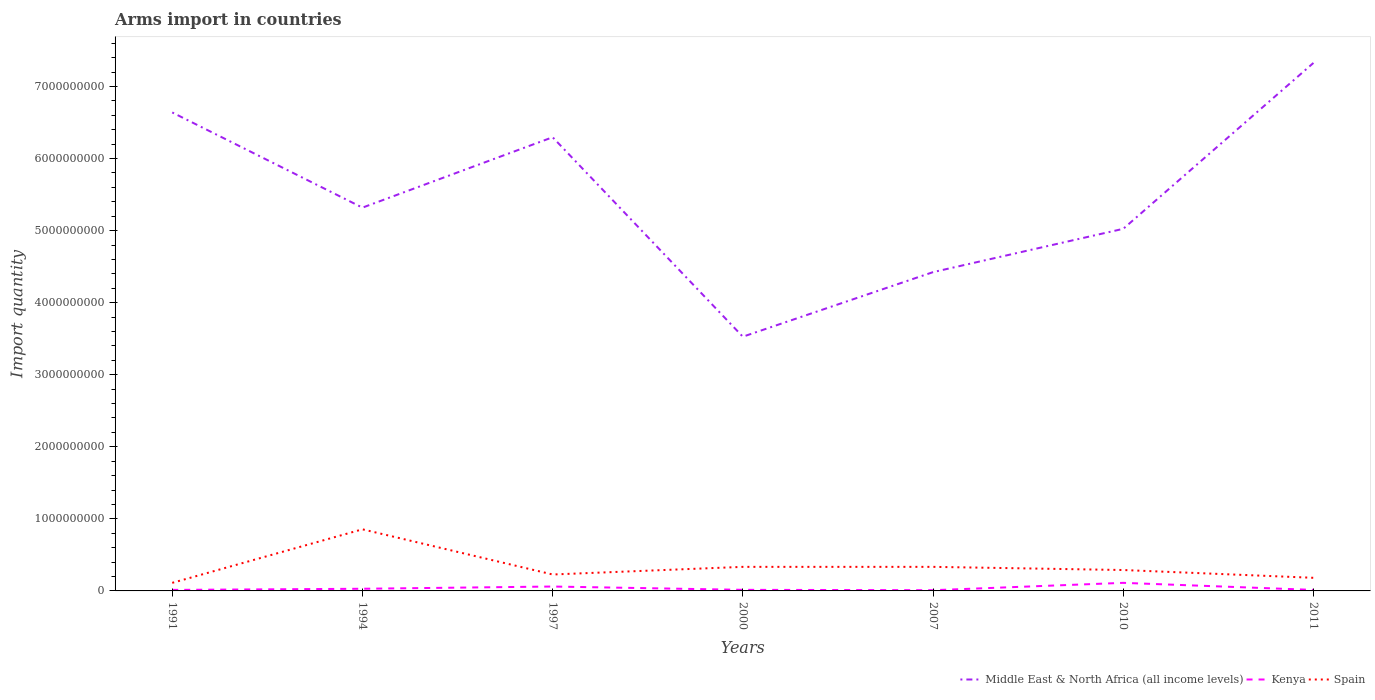Is the number of lines equal to the number of legend labels?
Offer a very short reply. Yes. Across all years, what is the maximum total arms import in Spain?
Give a very brief answer. 1.12e+08. In which year was the total arms import in Spain maximum?
Provide a short and direct response. 1991. What is the total total arms import in Spain in the graph?
Keep it short and to the point. 5.65e+08. What is the difference between the highest and the second highest total arms import in Spain?
Provide a succinct answer. 7.43e+08. How many years are there in the graph?
Keep it short and to the point. 7. Are the values on the major ticks of Y-axis written in scientific E-notation?
Your answer should be compact. No. How are the legend labels stacked?
Keep it short and to the point. Horizontal. What is the title of the graph?
Make the answer very short. Arms import in countries. What is the label or title of the Y-axis?
Your answer should be very brief. Import quantity. What is the Import quantity in Middle East & North Africa (all income levels) in 1991?
Keep it short and to the point. 6.64e+09. What is the Import quantity in Kenya in 1991?
Keep it short and to the point. 1.40e+07. What is the Import quantity in Spain in 1991?
Your answer should be very brief. 1.12e+08. What is the Import quantity in Middle East & North Africa (all income levels) in 1994?
Keep it short and to the point. 5.32e+09. What is the Import quantity in Kenya in 1994?
Make the answer very short. 3.00e+07. What is the Import quantity of Spain in 1994?
Offer a terse response. 8.55e+08. What is the Import quantity of Middle East & North Africa (all income levels) in 1997?
Provide a succinct answer. 6.30e+09. What is the Import quantity of Kenya in 1997?
Keep it short and to the point. 6.10e+07. What is the Import quantity in Spain in 1997?
Offer a terse response. 2.28e+08. What is the Import quantity in Middle East & North Africa (all income levels) in 2000?
Your answer should be compact. 3.53e+09. What is the Import quantity of Kenya in 2000?
Keep it short and to the point. 1.50e+07. What is the Import quantity in Spain in 2000?
Keep it short and to the point. 3.34e+08. What is the Import quantity in Middle East & North Africa (all income levels) in 2007?
Keep it short and to the point. 4.42e+09. What is the Import quantity of Kenya in 2007?
Ensure brevity in your answer.  1.00e+07. What is the Import quantity of Spain in 2007?
Offer a terse response. 3.34e+08. What is the Import quantity of Middle East & North Africa (all income levels) in 2010?
Provide a succinct answer. 5.02e+09. What is the Import quantity of Kenya in 2010?
Offer a terse response. 1.12e+08. What is the Import quantity in Spain in 2010?
Your answer should be very brief. 2.90e+08. What is the Import quantity in Middle East & North Africa (all income levels) in 2011?
Provide a short and direct response. 7.33e+09. What is the Import quantity in Kenya in 2011?
Your answer should be compact. 1.40e+07. What is the Import quantity in Spain in 2011?
Provide a succinct answer. 1.82e+08. Across all years, what is the maximum Import quantity in Middle East & North Africa (all income levels)?
Give a very brief answer. 7.33e+09. Across all years, what is the maximum Import quantity in Kenya?
Ensure brevity in your answer.  1.12e+08. Across all years, what is the maximum Import quantity in Spain?
Ensure brevity in your answer.  8.55e+08. Across all years, what is the minimum Import quantity in Middle East & North Africa (all income levels)?
Ensure brevity in your answer.  3.53e+09. Across all years, what is the minimum Import quantity of Kenya?
Your answer should be compact. 1.00e+07. Across all years, what is the minimum Import quantity of Spain?
Ensure brevity in your answer.  1.12e+08. What is the total Import quantity in Middle East & North Africa (all income levels) in the graph?
Your answer should be very brief. 3.86e+1. What is the total Import quantity of Kenya in the graph?
Give a very brief answer. 2.56e+08. What is the total Import quantity in Spain in the graph?
Make the answer very short. 2.34e+09. What is the difference between the Import quantity of Middle East & North Africa (all income levels) in 1991 and that in 1994?
Offer a very short reply. 1.32e+09. What is the difference between the Import quantity in Kenya in 1991 and that in 1994?
Give a very brief answer. -1.60e+07. What is the difference between the Import quantity of Spain in 1991 and that in 1994?
Offer a very short reply. -7.43e+08. What is the difference between the Import quantity in Middle East & North Africa (all income levels) in 1991 and that in 1997?
Give a very brief answer. 3.44e+08. What is the difference between the Import quantity in Kenya in 1991 and that in 1997?
Offer a terse response. -4.70e+07. What is the difference between the Import quantity in Spain in 1991 and that in 1997?
Your answer should be compact. -1.16e+08. What is the difference between the Import quantity of Middle East & North Africa (all income levels) in 1991 and that in 2000?
Offer a terse response. 3.11e+09. What is the difference between the Import quantity of Spain in 1991 and that in 2000?
Your answer should be compact. -2.22e+08. What is the difference between the Import quantity in Middle East & North Africa (all income levels) in 1991 and that in 2007?
Keep it short and to the point. 2.22e+09. What is the difference between the Import quantity of Spain in 1991 and that in 2007?
Keep it short and to the point. -2.22e+08. What is the difference between the Import quantity of Middle East & North Africa (all income levels) in 1991 and that in 2010?
Your answer should be very brief. 1.62e+09. What is the difference between the Import quantity in Kenya in 1991 and that in 2010?
Provide a succinct answer. -9.80e+07. What is the difference between the Import quantity in Spain in 1991 and that in 2010?
Your answer should be very brief. -1.78e+08. What is the difference between the Import quantity in Middle East & North Africa (all income levels) in 1991 and that in 2011?
Provide a succinct answer. -6.87e+08. What is the difference between the Import quantity in Kenya in 1991 and that in 2011?
Ensure brevity in your answer.  0. What is the difference between the Import quantity in Spain in 1991 and that in 2011?
Your answer should be very brief. -7.00e+07. What is the difference between the Import quantity in Middle East & North Africa (all income levels) in 1994 and that in 1997?
Your response must be concise. -9.77e+08. What is the difference between the Import quantity of Kenya in 1994 and that in 1997?
Offer a terse response. -3.10e+07. What is the difference between the Import quantity in Spain in 1994 and that in 1997?
Provide a short and direct response. 6.27e+08. What is the difference between the Import quantity in Middle East & North Africa (all income levels) in 1994 and that in 2000?
Offer a very short reply. 1.79e+09. What is the difference between the Import quantity of Kenya in 1994 and that in 2000?
Your response must be concise. 1.50e+07. What is the difference between the Import quantity in Spain in 1994 and that in 2000?
Offer a very short reply. 5.21e+08. What is the difference between the Import quantity of Middle East & North Africa (all income levels) in 1994 and that in 2007?
Keep it short and to the point. 8.95e+08. What is the difference between the Import quantity in Spain in 1994 and that in 2007?
Give a very brief answer. 5.21e+08. What is the difference between the Import quantity of Middle East & North Africa (all income levels) in 1994 and that in 2010?
Offer a terse response. 2.94e+08. What is the difference between the Import quantity in Kenya in 1994 and that in 2010?
Make the answer very short. -8.20e+07. What is the difference between the Import quantity in Spain in 1994 and that in 2010?
Offer a very short reply. 5.65e+08. What is the difference between the Import quantity of Middle East & North Africa (all income levels) in 1994 and that in 2011?
Provide a short and direct response. -2.01e+09. What is the difference between the Import quantity in Kenya in 1994 and that in 2011?
Keep it short and to the point. 1.60e+07. What is the difference between the Import quantity in Spain in 1994 and that in 2011?
Your answer should be compact. 6.73e+08. What is the difference between the Import quantity of Middle East & North Africa (all income levels) in 1997 and that in 2000?
Make the answer very short. 2.77e+09. What is the difference between the Import quantity in Kenya in 1997 and that in 2000?
Keep it short and to the point. 4.60e+07. What is the difference between the Import quantity in Spain in 1997 and that in 2000?
Your answer should be very brief. -1.06e+08. What is the difference between the Import quantity in Middle East & North Africa (all income levels) in 1997 and that in 2007?
Provide a succinct answer. 1.87e+09. What is the difference between the Import quantity in Kenya in 1997 and that in 2007?
Keep it short and to the point. 5.10e+07. What is the difference between the Import quantity of Spain in 1997 and that in 2007?
Offer a terse response. -1.06e+08. What is the difference between the Import quantity of Middle East & North Africa (all income levels) in 1997 and that in 2010?
Your response must be concise. 1.27e+09. What is the difference between the Import quantity in Kenya in 1997 and that in 2010?
Your answer should be very brief. -5.10e+07. What is the difference between the Import quantity of Spain in 1997 and that in 2010?
Offer a terse response. -6.20e+07. What is the difference between the Import quantity in Middle East & North Africa (all income levels) in 1997 and that in 2011?
Provide a short and direct response. -1.03e+09. What is the difference between the Import quantity of Kenya in 1997 and that in 2011?
Your answer should be compact. 4.70e+07. What is the difference between the Import quantity of Spain in 1997 and that in 2011?
Ensure brevity in your answer.  4.60e+07. What is the difference between the Import quantity of Middle East & North Africa (all income levels) in 2000 and that in 2007?
Ensure brevity in your answer.  -8.96e+08. What is the difference between the Import quantity in Kenya in 2000 and that in 2007?
Your answer should be compact. 5.00e+06. What is the difference between the Import quantity of Middle East & North Africa (all income levels) in 2000 and that in 2010?
Your response must be concise. -1.50e+09. What is the difference between the Import quantity in Kenya in 2000 and that in 2010?
Your answer should be compact. -9.70e+07. What is the difference between the Import quantity in Spain in 2000 and that in 2010?
Ensure brevity in your answer.  4.40e+07. What is the difference between the Import quantity in Middle East & North Africa (all income levels) in 2000 and that in 2011?
Your answer should be compact. -3.80e+09. What is the difference between the Import quantity in Kenya in 2000 and that in 2011?
Give a very brief answer. 1.00e+06. What is the difference between the Import quantity in Spain in 2000 and that in 2011?
Offer a very short reply. 1.52e+08. What is the difference between the Import quantity of Middle East & North Africa (all income levels) in 2007 and that in 2010?
Provide a short and direct response. -6.01e+08. What is the difference between the Import quantity in Kenya in 2007 and that in 2010?
Keep it short and to the point. -1.02e+08. What is the difference between the Import quantity in Spain in 2007 and that in 2010?
Make the answer very short. 4.40e+07. What is the difference between the Import quantity in Middle East & North Africa (all income levels) in 2007 and that in 2011?
Provide a succinct answer. -2.90e+09. What is the difference between the Import quantity of Spain in 2007 and that in 2011?
Give a very brief answer. 1.52e+08. What is the difference between the Import quantity of Middle East & North Africa (all income levels) in 2010 and that in 2011?
Your answer should be very brief. -2.30e+09. What is the difference between the Import quantity of Kenya in 2010 and that in 2011?
Provide a short and direct response. 9.80e+07. What is the difference between the Import quantity in Spain in 2010 and that in 2011?
Keep it short and to the point. 1.08e+08. What is the difference between the Import quantity of Middle East & North Africa (all income levels) in 1991 and the Import quantity of Kenya in 1994?
Your answer should be very brief. 6.61e+09. What is the difference between the Import quantity of Middle East & North Africa (all income levels) in 1991 and the Import quantity of Spain in 1994?
Make the answer very short. 5.78e+09. What is the difference between the Import quantity of Kenya in 1991 and the Import quantity of Spain in 1994?
Offer a terse response. -8.41e+08. What is the difference between the Import quantity of Middle East & North Africa (all income levels) in 1991 and the Import quantity of Kenya in 1997?
Offer a very short reply. 6.58e+09. What is the difference between the Import quantity in Middle East & North Africa (all income levels) in 1991 and the Import quantity in Spain in 1997?
Provide a short and direct response. 6.41e+09. What is the difference between the Import quantity in Kenya in 1991 and the Import quantity in Spain in 1997?
Your response must be concise. -2.14e+08. What is the difference between the Import quantity of Middle East & North Africa (all income levels) in 1991 and the Import quantity of Kenya in 2000?
Your answer should be very brief. 6.62e+09. What is the difference between the Import quantity of Middle East & North Africa (all income levels) in 1991 and the Import quantity of Spain in 2000?
Ensure brevity in your answer.  6.31e+09. What is the difference between the Import quantity in Kenya in 1991 and the Import quantity in Spain in 2000?
Provide a short and direct response. -3.20e+08. What is the difference between the Import quantity in Middle East & North Africa (all income levels) in 1991 and the Import quantity in Kenya in 2007?
Your response must be concise. 6.63e+09. What is the difference between the Import quantity of Middle East & North Africa (all income levels) in 1991 and the Import quantity of Spain in 2007?
Keep it short and to the point. 6.31e+09. What is the difference between the Import quantity in Kenya in 1991 and the Import quantity in Spain in 2007?
Give a very brief answer. -3.20e+08. What is the difference between the Import quantity of Middle East & North Africa (all income levels) in 1991 and the Import quantity of Kenya in 2010?
Offer a very short reply. 6.53e+09. What is the difference between the Import quantity in Middle East & North Africa (all income levels) in 1991 and the Import quantity in Spain in 2010?
Your answer should be compact. 6.35e+09. What is the difference between the Import quantity in Kenya in 1991 and the Import quantity in Spain in 2010?
Give a very brief answer. -2.76e+08. What is the difference between the Import quantity in Middle East & North Africa (all income levels) in 1991 and the Import quantity in Kenya in 2011?
Your response must be concise. 6.63e+09. What is the difference between the Import quantity of Middle East & North Africa (all income levels) in 1991 and the Import quantity of Spain in 2011?
Your answer should be very brief. 6.46e+09. What is the difference between the Import quantity in Kenya in 1991 and the Import quantity in Spain in 2011?
Your answer should be compact. -1.68e+08. What is the difference between the Import quantity of Middle East & North Africa (all income levels) in 1994 and the Import quantity of Kenya in 1997?
Provide a short and direct response. 5.26e+09. What is the difference between the Import quantity in Middle East & North Africa (all income levels) in 1994 and the Import quantity in Spain in 1997?
Your answer should be very brief. 5.09e+09. What is the difference between the Import quantity in Kenya in 1994 and the Import quantity in Spain in 1997?
Offer a very short reply. -1.98e+08. What is the difference between the Import quantity in Middle East & North Africa (all income levels) in 1994 and the Import quantity in Kenya in 2000?
Provide a short and direct response. 5.30e+09. What is the difference between the Import quantity in Middle East & North Africa (all income levels) in 1994 and the Import quantity in Spain in 2000?
Keep it short and to the point. 4.98e+09. What is the difference between the Import quantity of Kenya in 1994 and the Import quantity of Spain in 2000?
Your answer should be very brief. -3.04e+08. What is the difference between the Import quantity in Middle East & North Africa (all income levels) in 1994 and the Import quantity in Kenya in 2007?
Give a very brief answer. 5.31e+09. What is the difference between the Import quantity in Middle East & North Africa (all income levels) in 1994 and the Import quantity in Spain in 2007?
Give a very brief answer. 4.98e+09. What is the difference between the Import quantity of Kenya in 1994 and the Import quantity of Spain in 2007?
Keep it short and to the point. -3.04e+08. What is the difference between the Import quantity of Middle East & North Africa (all income levels) in 1994 and the Import quantity of Kenya in 2010?
Provide a succinct answer. 5.21e+09. What is the difference between the Import quantity of Middle East & North Africa (all income levels) in 1994 and the Import quantity of Spain in 2010?
Give a very brief answer. 5.03e+09. What is the difference between the Import quantity of Kenya in 1994 and the Import quantity of Spain in 2010?
Offer a terse response. -2.60e+08. What is the difference between the Import quantity in Middle East & North Africa (all income levels) in 1994 and the Import quantity in Kenya in 2011?
Keep it short and to the point. 5.30e+09. What is the difference between the Import quantity in Middle East & North Africa (all income levels) in 1994 and the Import quantity in Spain in 2011?
Your answer should be very brief. 5.14e+09. What is the difference between the Import quantity of Kenya in 1994 and the Import quantity of Spain in 2011?
Offer a terse response. -1.52e+08. What is the difference between the Import quantity of Middle East & North Africa (all income levels) in 1997 and the Import quantity of Kenya in 2000?
Ensure brevity in your answer.  6.28e+09. What is the difference between the Import quantity in Middle East & North Africa (all income levels) in 1997 and the Import quantity in Spain in 2000?
Your answer should be very brief. 5.96e+09. What is the difference between the Import quantity of Kenya in 1997 and the Import quantity of Spain in 2000?
Your answer should be very brief. -2.73e+08. What is the difference between the Import quantity of Middle East & North Africa (all income levels) in 1997 and the Import quantity of Kenya in 2007?
Provide a short and direct response. 6.29e+09. What is the difference between the Import quantity of Middle East & North Africa (all income levels) in 1997 and the Import quantity of Spain in 2007?
Keep it short and to the point. 5.96e+09. What is the difference between the Import quantity in Kenya in 1997 and the Import quantity in Spain in 2007?
Offer a terse response. -2.73e+08. What is the difference between the Import quantity in Middle East & North Africa (all income levels) in 1997 and the Import quantity in Kenya in 2010?
Your answer should be very brief. 6.18e+09. What is the difference between the Import quantity in Middle East & North Africa (all income levels) in 1997 and the Import quantity in Spain in 2010?
Your response must be concise. 6.01e+09. What is the difference between the Import quantity in Kenya in 1997 and the Import quantity in Spain in 2010?
Provide a succinct answer. -2.29e+08. What is the difference between the Import quantity of Middle East & North Africa (all income levels) in 1997 and the Import quantity of Kenya in 2011?
Provide a succinct answer. 6.28e+09. What is the difference between the Import quantity of Middle East & North Africa (all income levels) in 1997 and the Import quantity of Spain in 2011?
Give a very brief answer. 6.11e+09. What is the difference between the Import quantity of Kenya in 1997 and the Import quantity of Spain in 2011?
Offer a terse response. -1.21e+08. What is the difference between the Import quantity of Middle East & North Africa (all income levels) in 2000 and the Import quantity of Kenya in 2007?
Provide a succinct answer. 3.52e+09. What is the difference between the Import quantity of Middle East & North Africa (all income levels) in 2000 and the Import quantity of Spain in 2007?
Provide a short and direct response. 3.19e+09. What is the difference between the Import quantity of Kenya in 2000 and the Import quantity of Spain in 2007?
Ensure brevity in your answer.  -3.19e+08. What is the difference between the Import quantity in Middle East & North Africa (all income levels) in 2000 and the Import quantity in Kenya in 2010?
Your response must be concise. 3.42e+09. What is the difference between the Import quantity in Middle East & North Africa (all income levels) in 2000 and the Import quantity in Spain in 2010?
Your answer should be very brief. 3.24e+09. What is the difference between the Import quantity of Kenya in 2000 and the Import quantity of Spain in 2010?
Keep it short and to the point. -2.75e+08. What is the difference between the Import quantity of Middle East & North Africa (all income levels) in 2000 and the Import quantity of Kenya in 2011?
Offer a terse response. 3.51e+09. What is the difference between the Import quantity in Middle East & North Africa (all income levels) in 2000 and the Import quantity in Spain in 2011?
Provide a succinct answer. 3.35e+09. What is the difference between the Import quantity in Kenya in 2000 and the Import quantity in Spain in 2011?
Offer a terse response. -1.67e+08. What is the difference between the Import quantity of Middle East & North Africa (all income levels) in 2007 and the Import quantity of Kenya in 2010?
Make the answer very short. 4.31e+09. What is the difference between the Import quantity in Middle East & North Africa (all income levels) in 2007 and the Import quantity in Spain in 2010?
Keep it short and to the point. 4.13e+09. What is the difference between the Import quantity of Kenya in 2007 and the Import quantity of Spain in 2010?
Provide a short and direct response. -2.80e+08. What is the difference between the Import quantity of Middle East & North Africa (all income levels) in 2007 and the Import quantity of Kenya in 2011?
Make the answer very short. 4.41e+09. What is the difference between the Import quantity of Middle East & North Africa (all income levels) in 2007 and the Import quantity of Spain in 2011?
Offer a terse response. 4.24e+09. What is the difference between the Import quantity of Kenya in 2007 and the Import quantity of Spain in 2011?
Provide a short and direct response. -1.72e+08. What is the difference between the Import quantity in Middle East & North Africa (all income levels) in 2010 and the Import quantity in Kenya in 2011?
Offer a terse response. 5.01e+09. What is the difference between the Import quantity of Middle East & North Africa (all income levels) in 2010 and the Import quantity of Spain in 2011?
Your response must be concise. 4.84e+09. What is the difference between the Import quantity in Kenya in 2010 and the Import quantity in Spain in 2011?
Ensure brevity in your answer.  -7.00e+07. What is the average Import quantity in Middle East & North Africa (all income levels) per year?
Offer a very short reply. 5.51e+09. What is the average Import quantity of Kenya per year?
Offer a very short reply. 3.66e+07. What is the average Import quantity of Spain per year?
Make the answer very short. 3.34e+08. In the year 1991, what is the difference between the Import quantity in Middle East & North Africa (all income levels) and Import quantity in Kenya?
Make the answer very short. 6.63e+09. In the year 1991, what is the difference between the Import quantity in Middle East & North Africa (all income levels) and Import quantity in Spain?
Provide a short and direct response. 6.53e+09. In the year 1991, what is the difference between the Import quantity in Kenya and Import quantity in Spain?
Offer a terse response. -9.80e+07. In the year 1994, what is the difference between the Import quantity in Middle East & North Africa (all income levels) and Import quantity in Kenya?
Provide a succinct answer. 5.29e+09. In the year 1994, what is the difference between the Import quantity of Middle East & North Africa (all income levels) and Import quantity of Spain?
Your response must be concise. 4.46e+09. In the year 1994, what is the difference between the Import quantity of Kenya and Import quantity of Spain?
Make the answer very short. -8.25e+08. In the year 1997, what is the difference between the Import quantity in Middle East & North Africa (all income levels) and Import quantity in Kenya?
Ensure brevity in your answer.  6.24e+09. In the year 1997, what is the difference between the Import quantity in Middle East & North Africa (all income levels) and Import quantity in Spain?
Your response must be concise. 6.07e+09. In the year 1997, what is the difference between the Import quantity of Kenya and Import quantity of Spain?
Your answer should be compact. -1.67e+08. In the year 2000, what is the difference between the Import quantity of Middle East & North Africa (all income levels) and Import quantity of Kenya?
Ensure brevity in your answer.  3.51e+09. In the year 2000, what is the difference between the Import quantity in Middle East & North Africa (all income levels) and Import quantity in Spain?
Keep it short and to the point. 3.19e+09. In the year 2000, what is the difference between the Import quantity of Kenya and Import quantity of Spain?
Ensure brevity in your answer.  -3.19e+08. In the year 2007, what is the difference between the Import quantity in Middle East & North Africa (all income levels) and Import quantity in Kenya?
Offer a very short reply. 4.41e+09. In the year 2007, what is the difference between the Import quantity of Middle East & North Africa (all income levels) and Import quantity of Spain?
Give a very brief answer. 4.09e+09. In the year 2007, what is the difference between the Import quantity of Kenya and Import quantity of Spain?
Offer a very short reply. -3.24e+08. In the year 2010, what is the difference between the Import quantity of Middle East & North Africa (all income levels) and Import quantity of Kenya?
Offer a very short reply. 4.91e+09. In the year 2010, what is the difference between the Import quantity in Middle East & North Africa (all income levels) and Import quantity in Spain?
Make the answer very short. 4.74e+09. In the year 2010, what is the difference between the Import quantity of Kenya and Import quantity of Spain?
Offer a terse response. -1.78e+08. In the year 2011, what is the difference between the Import quantity in Middle East & North Africa (all income levels) and Import quantity in Kenya?
Ensure brevity in your answer.  7.31e+09. In the year 2011, what is the difference between the Import quantity of Middle East & North Africa (all income levels) and Import quantity of Spain?
Make the answer very short. 7.14e+09. In the year 2011, what is the difference between the Import quantity in Kenya and Import quantity in Spain?
Keep it short and to the point. -1.68e+08. What is the ratio of the Import quantity of Middle East & North Africa (all income levels) in 1991 to that in 1994?
Make the answer very short. 1.25. What is the ratio of the Import quantity of Kenya in 1991 to that in 1994?
Give a very brief answer. 0.47. What is the ratio of the Import quantity in Spain in 1991 to that in 1994?
Keep it short and to the point. 0.13. What is the ratio of the Import quantity in Middle East & North Africa (all income levels) in 1991 to that in 1997?
Your answer should be compact. 1.05. What is the ratio of the Import quantity in Kenya in 1991 to that in 1997?
Your answer should be very brief. 0.23. What is the ratio of the Import quantity in Spain in 1991 to that in 1997?
Your response must be concise. 0.49. What is the ratio of the Import quantity of Middle East & North Africa (all income levels) in 1991 to that in 2000?
Provide a short and direct response. 1.88. What is the ratio of the Import quantity of Kenya in 1991 to that in 2000?
Offer a terse response. 0.93. What is the ratio of the Import quantity of Spain in 1991 to that in 2000?
Provide a short and direct response. 0.34. What is the ratio of the Import quantity in Middle East & North Africa (all income levels) in 1991 to that in 2007?
Make the answer very short. 1.5. What is the ratio of the Import quantity of Kenya in 1991 to that in 2007?
Offer a very short reply. 1.4. What is the ratio of the Import quantity of Spain in 1991 to that in 2007?
Give a very brief answer. 0.34. What is the ratio of the Import quantity of Middle East & North Africa (all income levels) in 1991 to that in 2010?
Offer a terse response. 1.32. What is the ratio of the Import quantity of Kenya in 1991 to that in 2010?
Provide a succinct answer. 0.12. What is the ratio of the Import quantity in Spain in 1991 to that in 2010?
Offer a very short reply. 0.39. What is the ratio of the Import quantity of Middle East & North Africa (all income levels) in 1991 to that in 2011?
Your response must be concise. 0.91. What is the ratio of the Import quantity of Spain in 1991 to that in 2011?
Give a very brief answer. 0.62. What is the ratio of the Import quantity of Middle East & North Africa (all income levels) in 1994 to that in 1997?
Make the answer very short. 0.84. What is the ratio of the Import quantity of Kenya in 1994 to that in 1997?
Ensure brevity in your answer.  0.49. What is the ratio of the Import quantity of Spain in 1994 to that in 1997?
Your answer should be compact. 3.75. What is the ratio of the Import quantity of Middle East & North Africa (all income levels) in 1994 to that in 2000?
Offer a very short reply. 1.51. What is the ratio of the Import quantity of Kenya in 1994 to that in 2000?
Keep it short and to the point. 2. What is the ratio of the Import quantity in Spain in 1994 to that in 2000?
Make the answer very short. 2.56. What is the ratio of the Import quantity in Middle East & North Africa (all income levels) in 1994 to that in 2007?
Your answer should be compact. 1.2. What is the ratio of the Import quantity of Kenya in 1994 to that in 2007?
Your answer should be compact. 3. What is the ratio of the Import quantity in Spain in 1994 to that in 2007?
Your answer should be very brief. 2.56. What is the ratio of the Import quantity in Middle East & North Africa (all income levels) in 1994 to that in 2010?
Provide a succinct answer. 1.06. What is the ratio of the Import quantity of Kenya in 1994 to that in 2010?
Offer a very short reply. 0.27. What is the ratio of the Import quantity in Spain in 1994 to that in 2010?
Your answer should be very brief. 2.95. What is the ratio of the Import quantity of Middle East & North Africa (all income levels) in 1994 to that in 2011?
Your answer should be compact. 0.73. What is the ratio of the Import quantity of Kenya in 1994 to that in 2011?
Your answer should be compact. 2.14. What is the ratio of the Import quantity of Spain in 1994 to that in 2011?
Your response must be concise. 4.7. What is the ratio of the Import quantity of Middle East & North Africa (all income levels) in 1997 to that in 2000?
Make the answer very short. 1.78. What is the ratio of the Import quantity of Kenya in 1997 to that in 2000?
Offer a very short reply. 4.07. What is the ratio of the Import quantity in Spain in 1997 to that in 2000?
Your response must be concise. 0.68. What is the ratio of the Import quantity in Middle East & North Africa (all income levels) in 1997 to that in 2007?
Give a very brief answer. 1.42. What is the ratio of the Import quantity of Spain in 1997 to that in 2007?
Give a very brief answer. 0.68. What is the ratio of the Import quantity of Middle East & North Africa (all income levels) in 1997 to that in 2010?
Your response must be concise. 1.25. What is the ratio of the Import quantity in Kenya in 1997 to that in 2010?
Your response must be concise. 0.54. What is the ratio of the Import quantity in Spain in 1997 to that in 2010?
Your answer should be very brief. 0.79. What is the ratio of the Import quantity of Middle East & North Africa (all income levels) in 1997 to that in 2011?
Ensure brevity in your answer.  0.86. What is the ratio of the Import quantity in Kenya in 1997 to that in 2011?
Offer a very short reply. 4.36. What is the ratio of the Import quantity of Spain in 1997 to that in 2011?
Provide a short and direct response. 1.25. What is the ratio of the Import quantity in Middle East & North Africa (all income levels) in 2000 to that in 2007?
Make the answer very short. 0.8. What is the ratio of the Import quantity in Kenya in 2000 to that in 2007?
Offer a terse response. 1.5. What is the ratio of the Import quantity in Spain in 2000 to that in 2007?
Your answer should be compact. 1. What is the ratio of the Import quantity of Middle East & North Africa (all income levels) in 2000 to that in 2010?
Keep it short and to the point. 0.7. What is the ratio of the Import quantity in Kenya in 2000 to that in 2010?
Offer a very short reply. 0.13. What is the ratio of the Import quantity of Spain in 2000 to that in 2010?
Give a very brief answer. 1.15. What is the ratio of the Import quantity in Middle East & North Africa (all income levels) in 2000 to that in 2011?
Offer a very short reply. 0.48. What is the ratio of the Import quantity in Kenya in 2000 to that in 2011?
Keep it short and to the point. 1.07. What is the ratio of the Import quantity of Spain in 2000 to that in 2011?
Provide a short and direct response. 1.84. What is the ratio of the Import quantity in Middle East & North Africa (all income levels) in 2007 to that in 2010?
Your answer should be compact. 0.88. What is the ratio of the Import quantity of Kenya in 2007 to that in 2010?
Provide a short and direct response. 0.09. What is the ratio of the Import quantity in Spain in 2007 to that in 2010?
Make the answer very short. 1.15. What is the ratio of the Import quantity in Middle East & North Africa (all income levels) in 2007 to that in 2011?
Keep it short and to the point. 0.6. What is the ratio of the Import quantity in Kenya in 2007 to that in 2011?
Keep it short and to the point. 0.71. What is the ratio of the Import quantity of Spain in 2007 to that in 2011?
Your answer should be compact. 1.84. What is the ratio of the Import quantity of Middle East & North Africa (all income levels) in 2010 to that in 2011?
Ensure brevity in your answer.  0.69. What is the ratio of the Import quantity in Spain in 2010 to that in 2011?
Give a very brief answer. 1.59. What is the difference between the highest and the second highest Import quantity of Middle East & North Africa (all income levels)?
Give a very brief answer. 6.87e+08. What is the difference between the highest and the second highest Import quantity of Kenya?
Ensure brevity in your answer.  5.10e+07. What is the difference between the highest and the second highest Import quantity of Spain?
Make the answer very short. 5.21e+08. What is the difference between the highest and the lowest Import quantity in Middle East & North Africa (all income levels)?
Ensure brevity in your answer.  3.80e+09. What is the difference between the highest and the lowest Import quantity of Kenya?
Give a very brief answer. 1.02e+08. What is the difference between the highest and the lowest Import quantity in Spain?
Your response must be concise. 7.43e+08. 